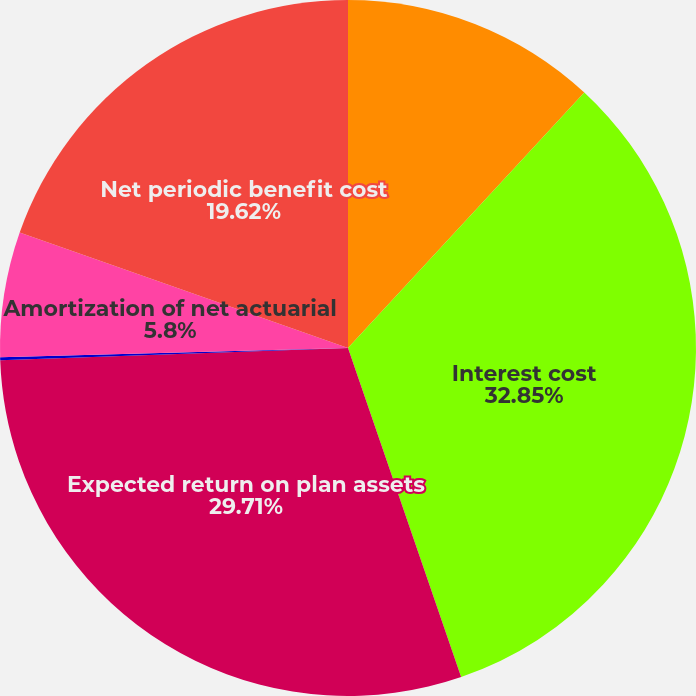<chart> <loc_0><loc_0><loc_500><loc_500><pie_chart><fcel>Service cost<fcel>Interest cost<fcel>Expected return on plan assets<fcel>Amortization of net prior<fcel>Amortization of net actuarial<fcel>Net periodic benefit cost<nl><fcel>11.88%<fcel>32.85%<fcel>29.71%<fcel>0.14%<fcel>5.8%<fcel>19.62%<nl></chart> 